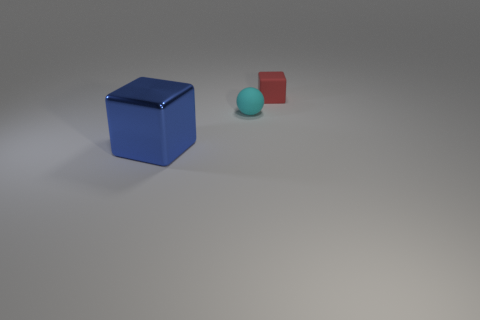Add 3 tiny matte blocks. How many objects exist? 6 Subtract all blue cubes. How many cubes are left? 1 Subtract 1 balls. How many balls are left? 0 Subtract all blue cubes. How many gray spheres are left? 0 Subtract all tiny cyan spheres. Subtract all tiny red objects. How many objects are left? 1 Add 3 matte blocks. How many matte blocks are left? 4 Add 1 red rubber blocks. How many red rubber blocks exist? 2 Subtract 1 cyan spheres. How many objects are left? 2 Subtract all blocks. How many objects are left? 1 Subtract all purple blocks. Subtract all cyan cylinders. How many blocks are left? 2 